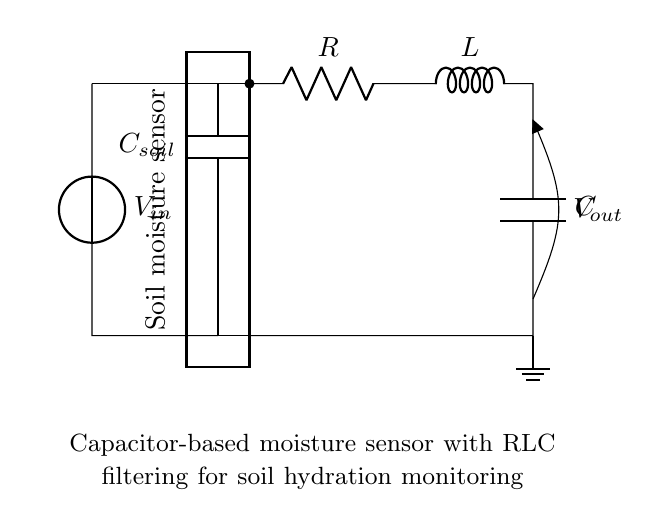What is the type of sensor used in this circuit? The circuit diagram indicates a soil moisture sensor, which is evident from the labeled component between the input voltage and the filter section.
Answer: Soil moisture sensor What component isolates the voltage output in this circuit? The capacitor, labeled as C within the RLC filter section, isolates the voltage by blocking DC while allowing AC signals to pass through, which is characteristic of filtering circuits.
Answer: Capacitor Which component is connected directly to the input voltage? The soil moisture sensor, denoted as C soil, is connected directly to the input voltage as it forms the first stage of the circuit before the RLC components.
Answer: Soil moisture sensor What is the voltage source in the circuit labeled as? The voltage source is labeled as V in the circuit, which signifies the supplied voltage for the operation of the entire circuit.
Answer: V in Explain the role of the RLC filter in this circuit. The RLC filter, composed of the resistor, inductor, and capacitor, is designed to filter the output signal from the soil moisture sensor, reducing noise and allowing only specific frequencies related to moisture content to pass through for accurate monitoring.
Answer: Filtering How many components are involved in the RLC filter? The RLC filter consists of three components: a resistor, an inductor, and a capacitor, where each plays a distinct role in filtering the signal.
Answer: Three Where is the output voltage measured in this circuit? The output voltage, labeled V out, is measured across the capacitor located at the output of the RLC filter section, indicating that it reflects the filtered voltage signal.
Answer: Output across the capacitor 